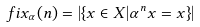<formula> <loc_0><loc_0><loc_500><loc_500>\ f i x _ { \alpha } ( n ) = | \{ x \in X | { \alpha } ^ { n } x = x \} |</formula> 